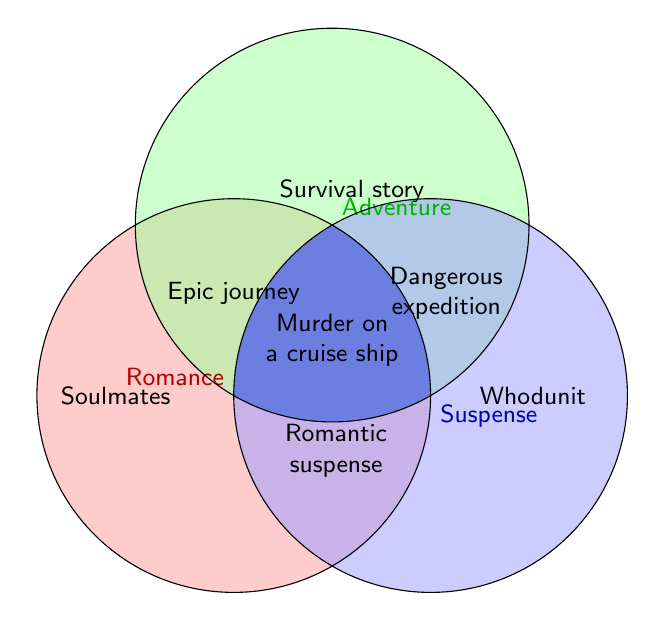Which theme is represented in all three circles? "Murder on a cruise ship" is located at the intersection of all three circles, indicating it falls under Romance, Adventure, and Suspense.
Answer: Murder on a cruise ship Which themes fall under the Romance circle but not under the Adventure or Suspense circles? Looking at the leftmost circle labeled Romance that does not overlap with the other two, the themes are "Soulmates" and "Happily ever after."
Answer: Soulmates, Happily ever after What themes involve an overlap between Romance and Suspense? The regions where the Romance and Suspense circles overlap but do not include the Adventure region contain "Romantic suspense" and "Stalker ex-lover."
Answer: Romantic suspense, Stalker ex-lover Compare the number of themes covered by Adventure alone to those covered by Suspense alone. The Adventure circle alone has "Survival story," Quest," and "Exploration," totaling 3 themes. The Suspense circle alone has "Whodunit," "Conspiracy theory," and "Psychological thriller," also totaling 3 themes.
Answer: Equal Identify a theme that combines Romance and Adventure but excludes Suspense. Analyzing the overlapping region of Romance and Adventure circles excluding Suspense, the theme identified is "Epic journey."
Answer: Epic journey Which theme represents a concept related to suspense in an adventure but not involving romance? The area where the Adventure and Suspense circles overlap, excluding Romance, has "Dangerous expedition."
Answer: Dangerous expedition How many total unique themes are illustrated in the diagram? There are seven unique categories, each represented either alone or in intersections: "Soulmates," "Survival story," "Whodunit," "Epic journey," "Romantic suspense," "Dangerous expedition," and "Murder on a cruise ship," totaling 7 themes.
Answer: 7 Is there a theme that mixes Romance, Suspense, but not Adventure? In the sections where Romance and Suspense overlap excluding Adventure, we find "Romantic suspense" and "Stalker ex-lover." Therefore, "Stalker ex-lover" fits the description.
Answer: Stalker ex-lover 